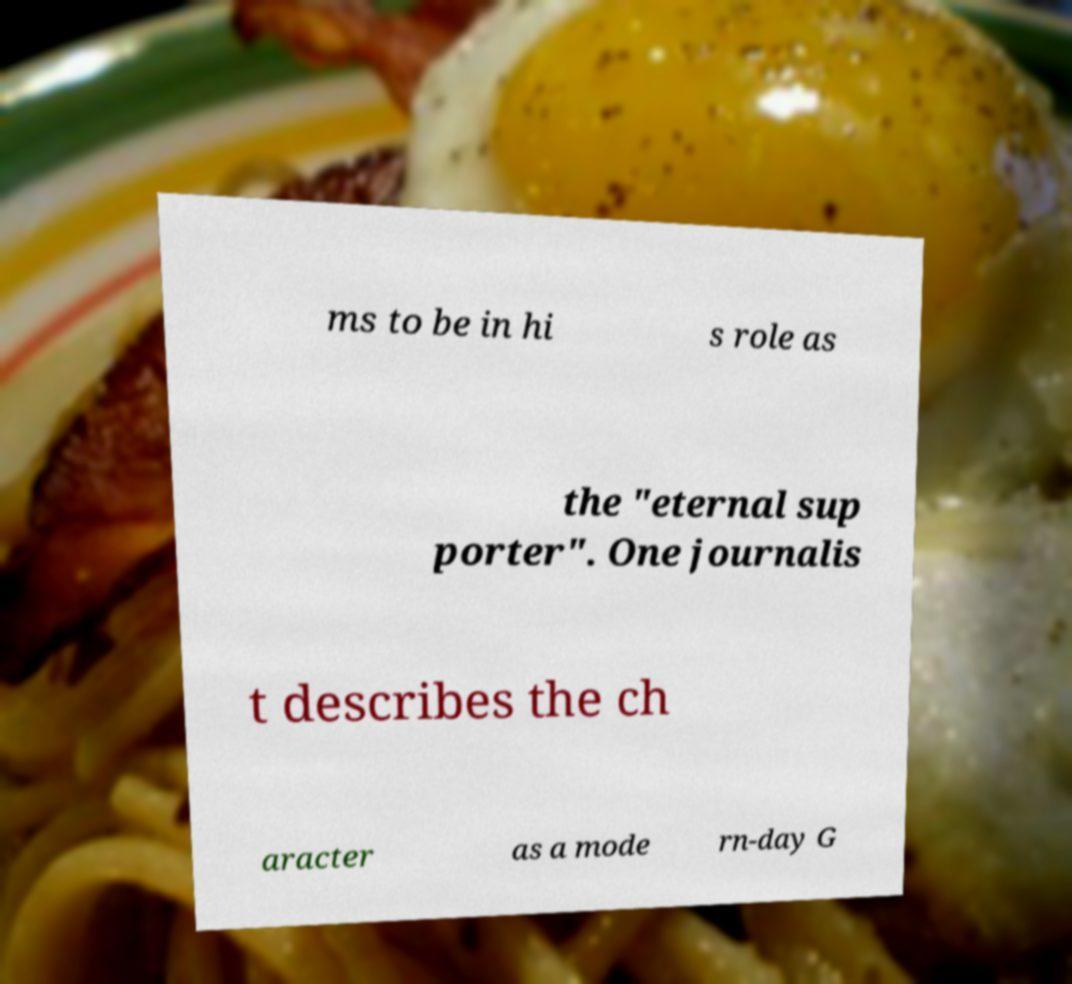For documentation purposes, I need the text within this image transcribed. Could you provide that? ms to be in hi s role as the "eternal sup porter". One journalis t describes the ch aracter as a mode rn-day G 